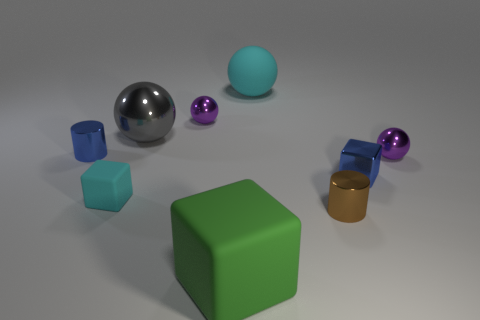Subtract all tiny cubes. How many cubes are left? 1 Subtract 1 cubes. How many cubes are left? 2 Add 1 big purple metallic blocks. How many objects exist? 10 Subtract all green balls. Subtract all purple cubes. How many balls are left? 4 Subtract all cubes. How many objects are left? 6 Subtract all red cubes. Subtract all small blocks. How many objects are left? 7 Add 3 tiny blue cylinders. How many tiny blue cylinders are left? 4 Add 3 green rubber blocks. How many green rubber blocks exist? 4 Subtract 0 yellow blocks. How many objects are left? 9 